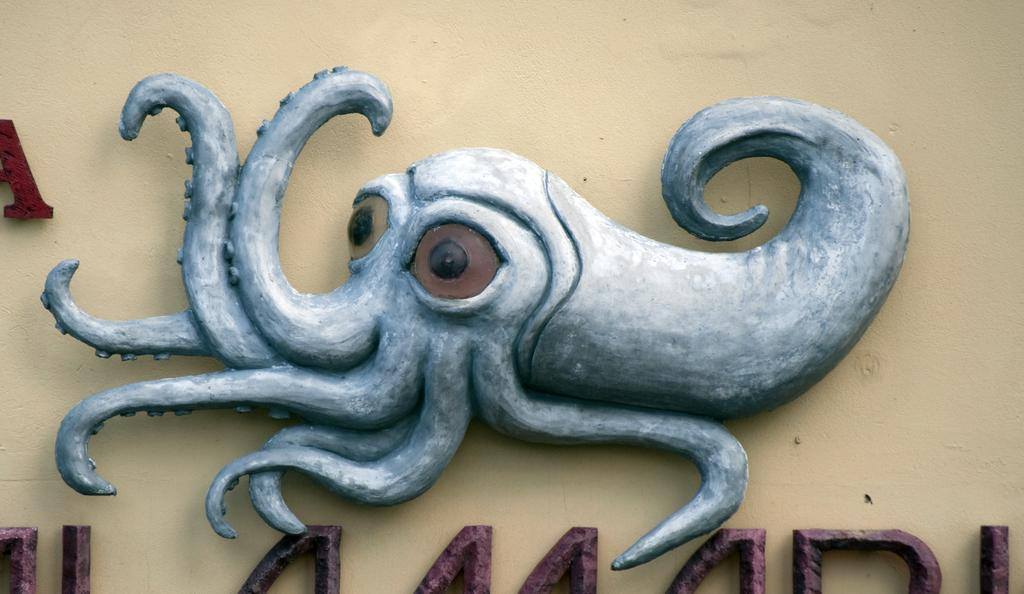What is the main subject of the image? There is a statue of an octopus in the image. What else can be seen in the image besides the octopus statue? There is text on the wall in the image. What type of bird is perched on the farmer's shoulder in the image? There is no farmer or bird present in the image; it features a statue of an octopus and text on the wall. 